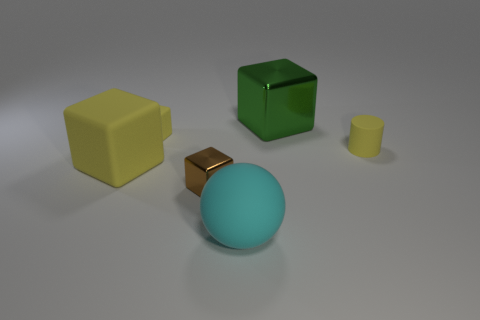Subtract all tiny yellow matte blocks. How many blocks are left? 3 Subtract all green spheres. How many yellow blocks are left? 2 Subtract all green blocks. How many blocks are left? 3 Subtract 2 blocks. How many blocks are left? 2 Add 3 green shiny things. How many objects exist? 9 Subtract all cubes. How many objects are left? 2 Subtract all purple blocks. Subtract all cyan balls. How many blocks are left? 4 Add 2 small yellow rubber objects. How many small yellow rubber objects exist? 4 Subtract 1 green cubes. How many objects are left? 5 Subtract all small gray matte things. Subtract all small brown things. How many objects are left? 5 